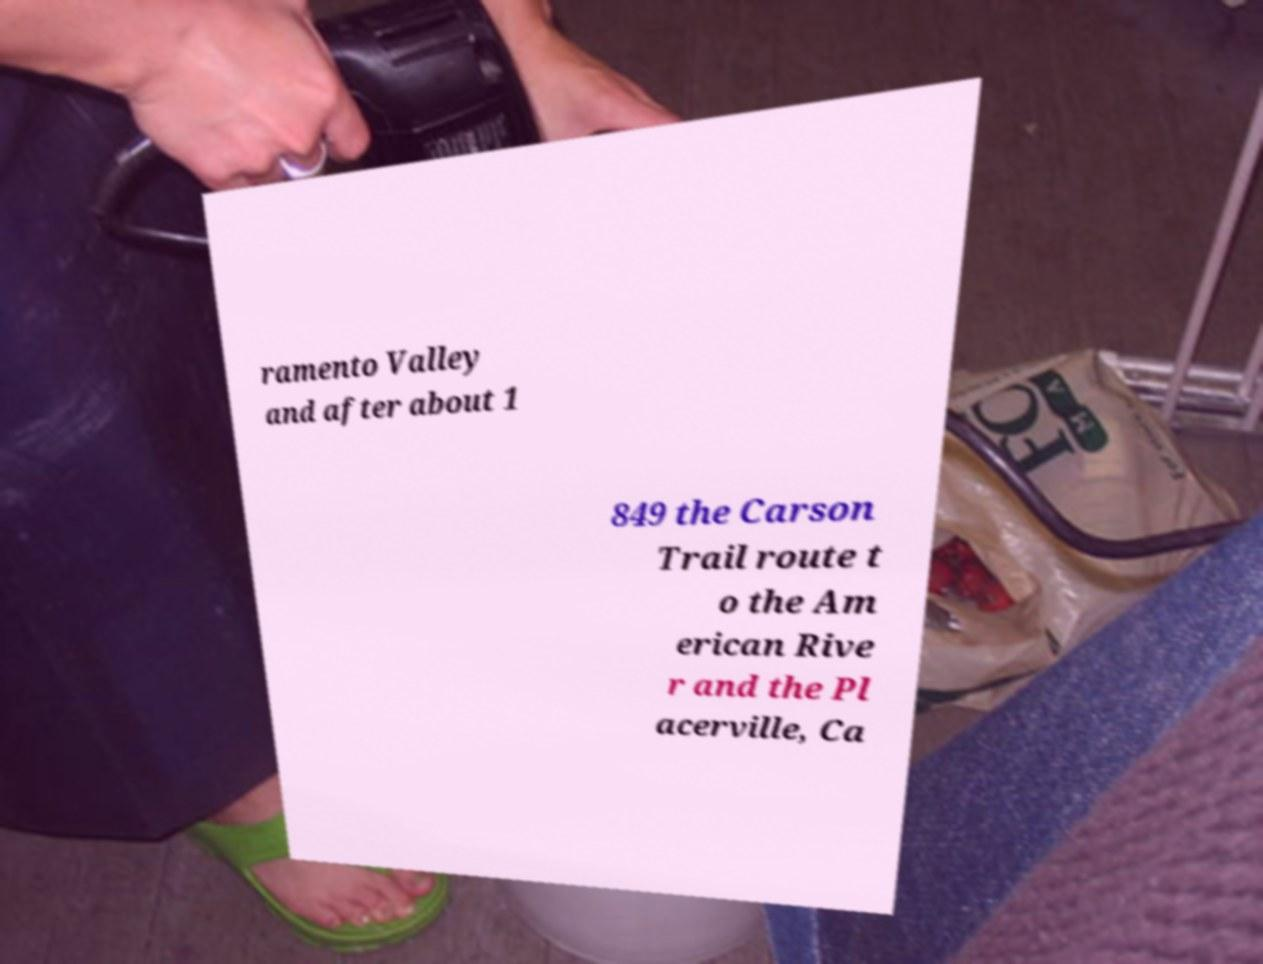Please identify and transcribe the text found in this image. ramento Valley and after about 1 849 the Carson Trail route t o the Am erican Rive r and the Pl acerville, Ca 